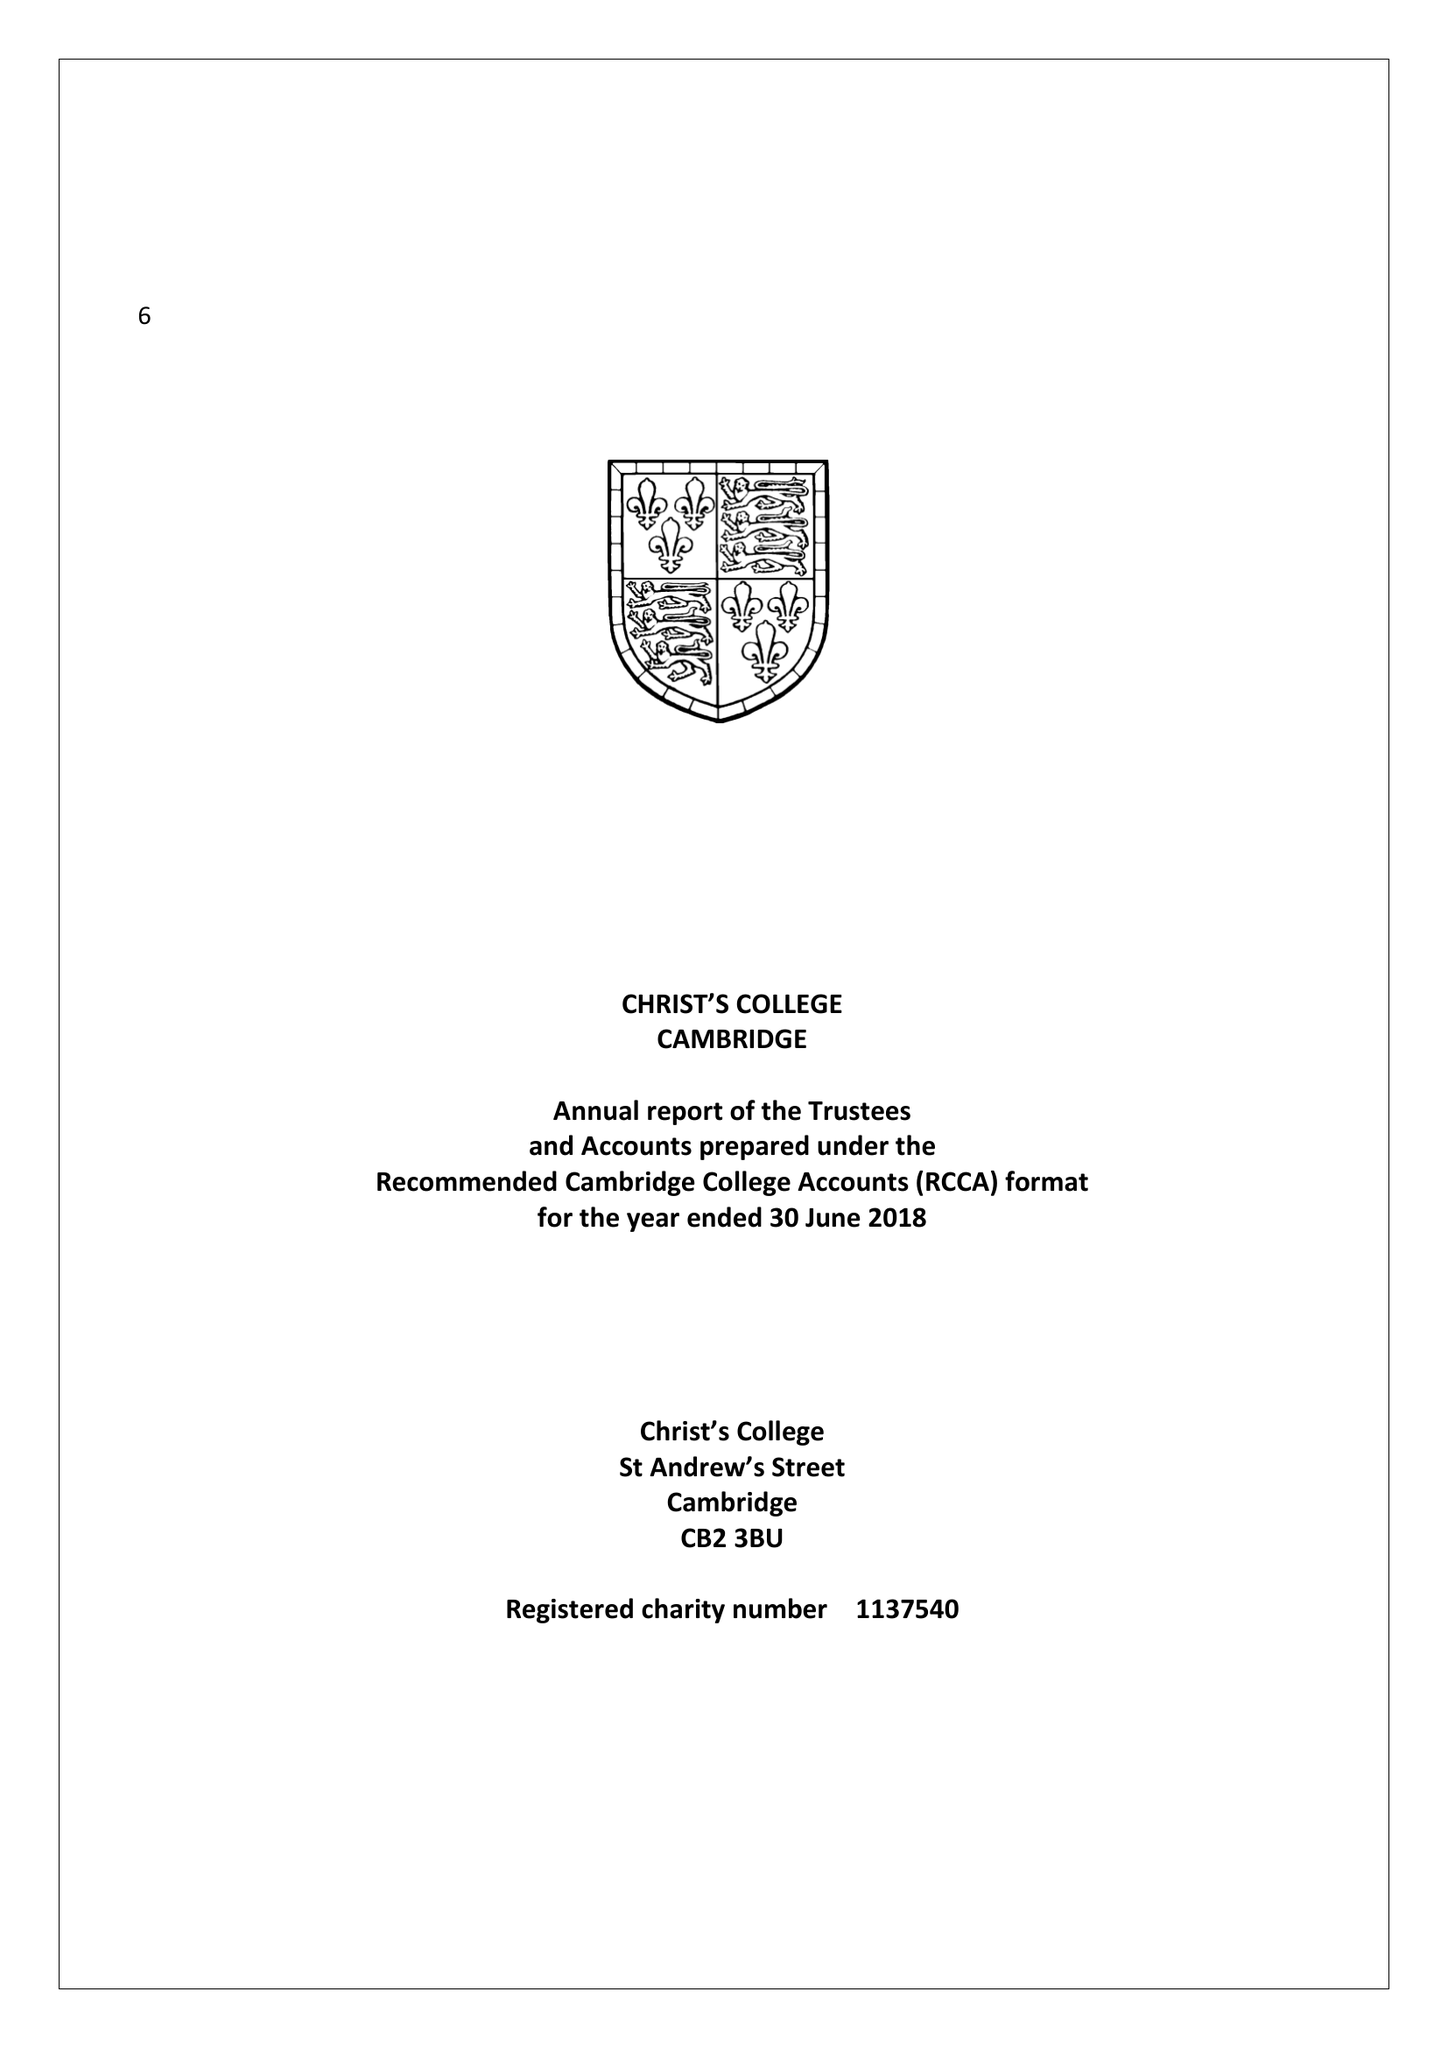What is the value for the report_date?
Answer the question using a single word or phrase. 2018-06-30 